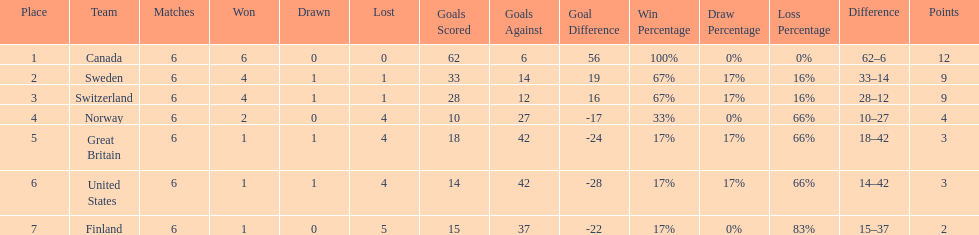How many teams won at least 4 matches? 3. 